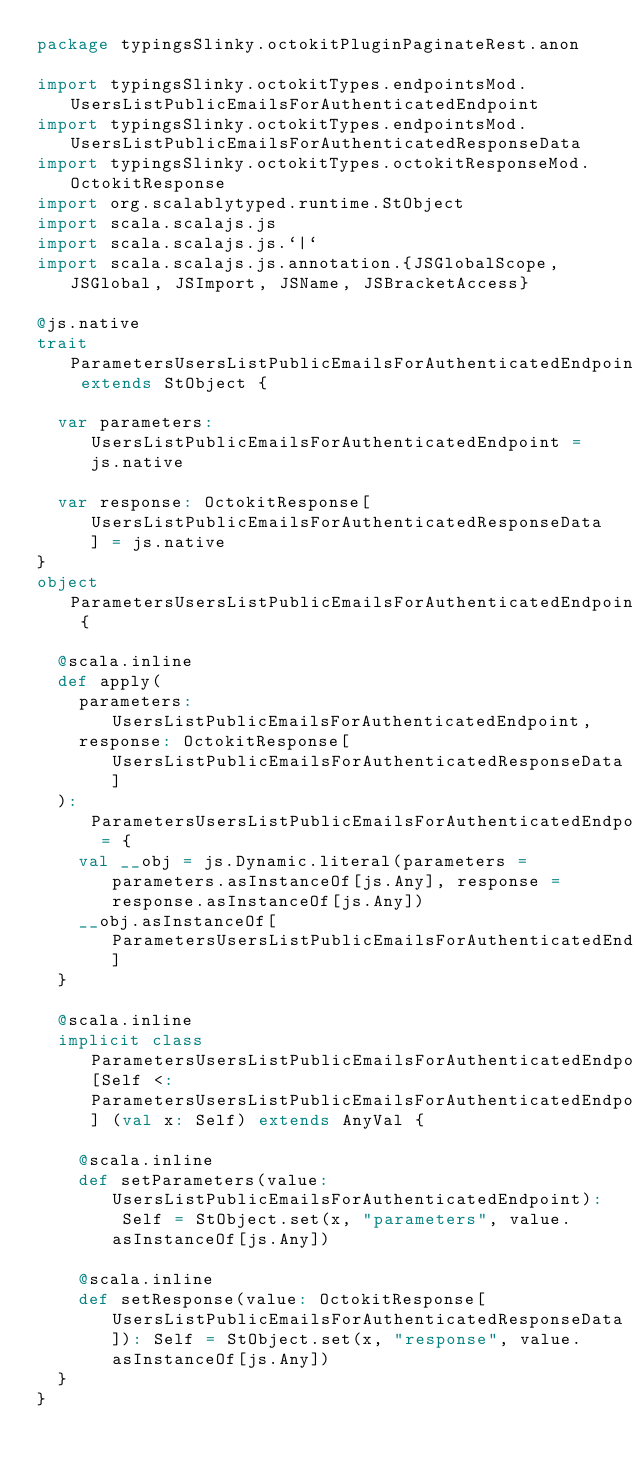Convert code to text. <code><loc_0><loc_0><loc_500><loc_500><_Scala_>package typingsSlinky.octokitPluginPaginateRest.anon

import typingsSlinky.octokitTypes.endpointsMod.UsersListPublicEmailsForAuthenticatedEndpoint
import typingsSlinky.octokitTypes.endpointsMod.UsersListPublicEmailsForAuthenticatedResponseData
import typingsSlinky.octokitTypes.octokitResponseMod.OctokitResponse
import org.scalablytyped.runtime.StObject
import scala.scalajs.js
import scala.scalajs.js.`|`
import scala.scalajs.js.annotation.{JSGlobalScope, JSGlobal, JSImport, JSName, JSBracketAccess}

@js.native
trait ParametersUsersListPublicEmailsForAuthenticatedEndpoint extends StObject {
  
  var parameters: UsersListPublicEmailsForAuthenticatedEndpoint = js.native
  
  var response: OctokitResponse[UsersListPublicEmailsForAuthenticatedResponseData] = js.native
}
object ParametersUsersListPublicEmailsForAuthenticatedEndpoint {
  
  @scala.inline
  def apply(
    parameters: UsersListPublicEmailsForAuthenticatedEndpoint,
    response: OctokitResponse[UsersListPublicEmailsForAuthenticatedResponseData]
  ): ParametersUsersListPublicEmailsForAuthenticatedEndpoint = {
    val __obj = js.Dynamic.literal(parameters = parameters.asInstanceOf[js.Any], response = response.asInstanceOf[js.Any])
    __obj.asInstanceOf[ParametersUsersListPublicEmailsForAuthenticatedEndpoint]
  }
  
  @scala.inline
  implicit class ParametersUsersListPublicEmailsForAuthenticatedEndpointMutableBuilder[Self <: ParametersUsersListPublicEmailsForAuthenticatedEndpoint] (val x: Self) extends AnyVal {
    
    @scala.inline
    def setParameters(value: UsersListPublicEmailsForAuthenticatedEndpoint): Self = StObject.set(x, "parameters", value.asInstanceOf[js.Any])
    
    @scala.inline
    def setResponse(value: OctokitResponse[UsersListPublicEmailsForAuthenticatedResponseData]): Self = StObject.set(x, "response", value.asInstanceOf[js.Any])
  }
}
</code> 